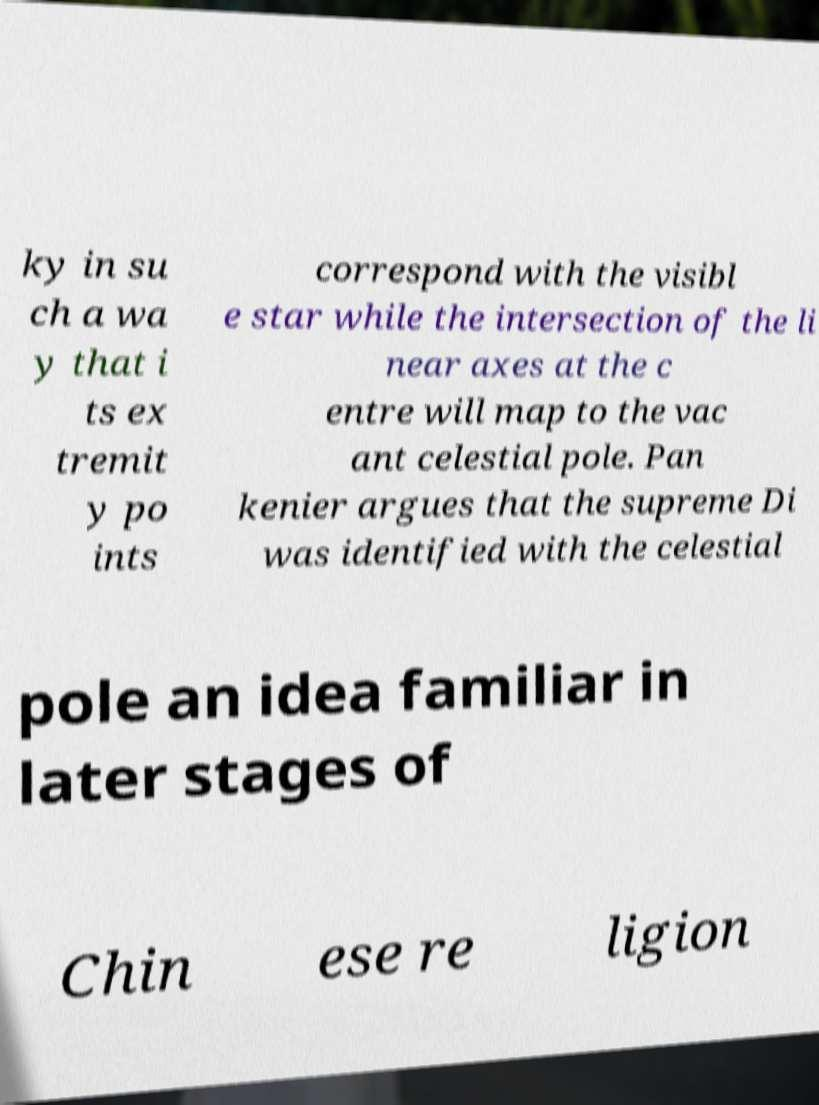Please read and relay the text visible in this image. What does it say? ky in su ch a wa y that i ts ex tremit y po ints correspond with the visibl e star while the intersection of the li near axes at the c entre will map to the vac ant celestial pole. Pan kenier argues that the supreme Di was identified with the celestial pole an idea familiar in later stages of Chin ese re ligion 